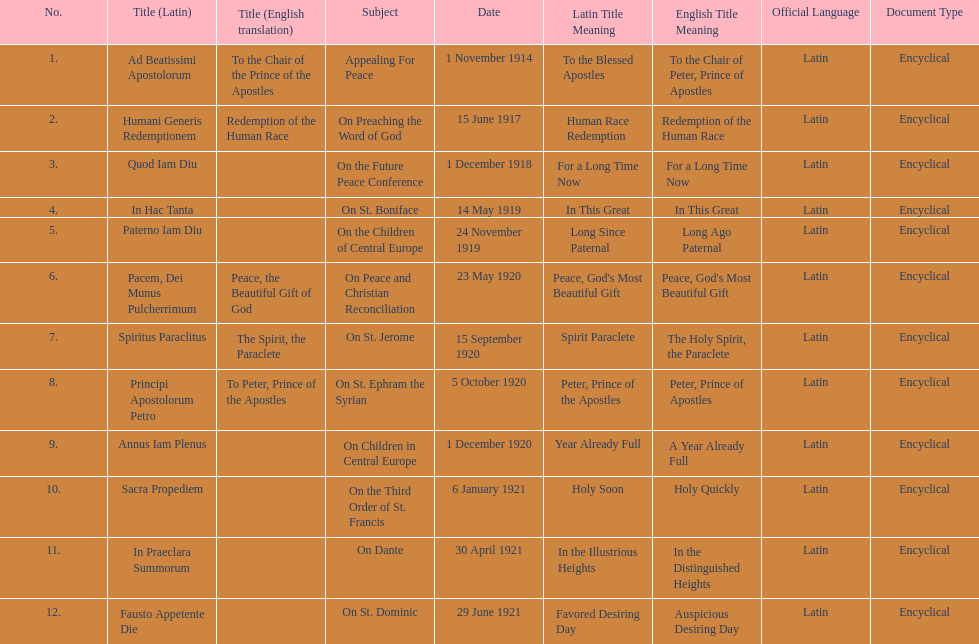What is the total number of encyclicals to take place in december? 2. 